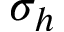Convert formula to latex. <formula><loc_0><loc_0><loc_500><loc_500>\sigma _ { h }</formula> 